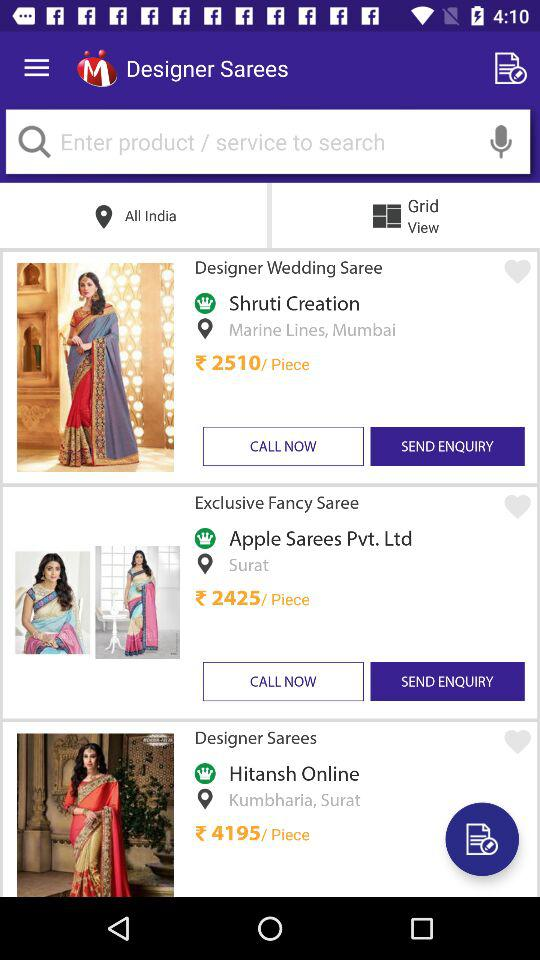How many items are located in Surat?
Answer the question using a single word or phrase. 2 